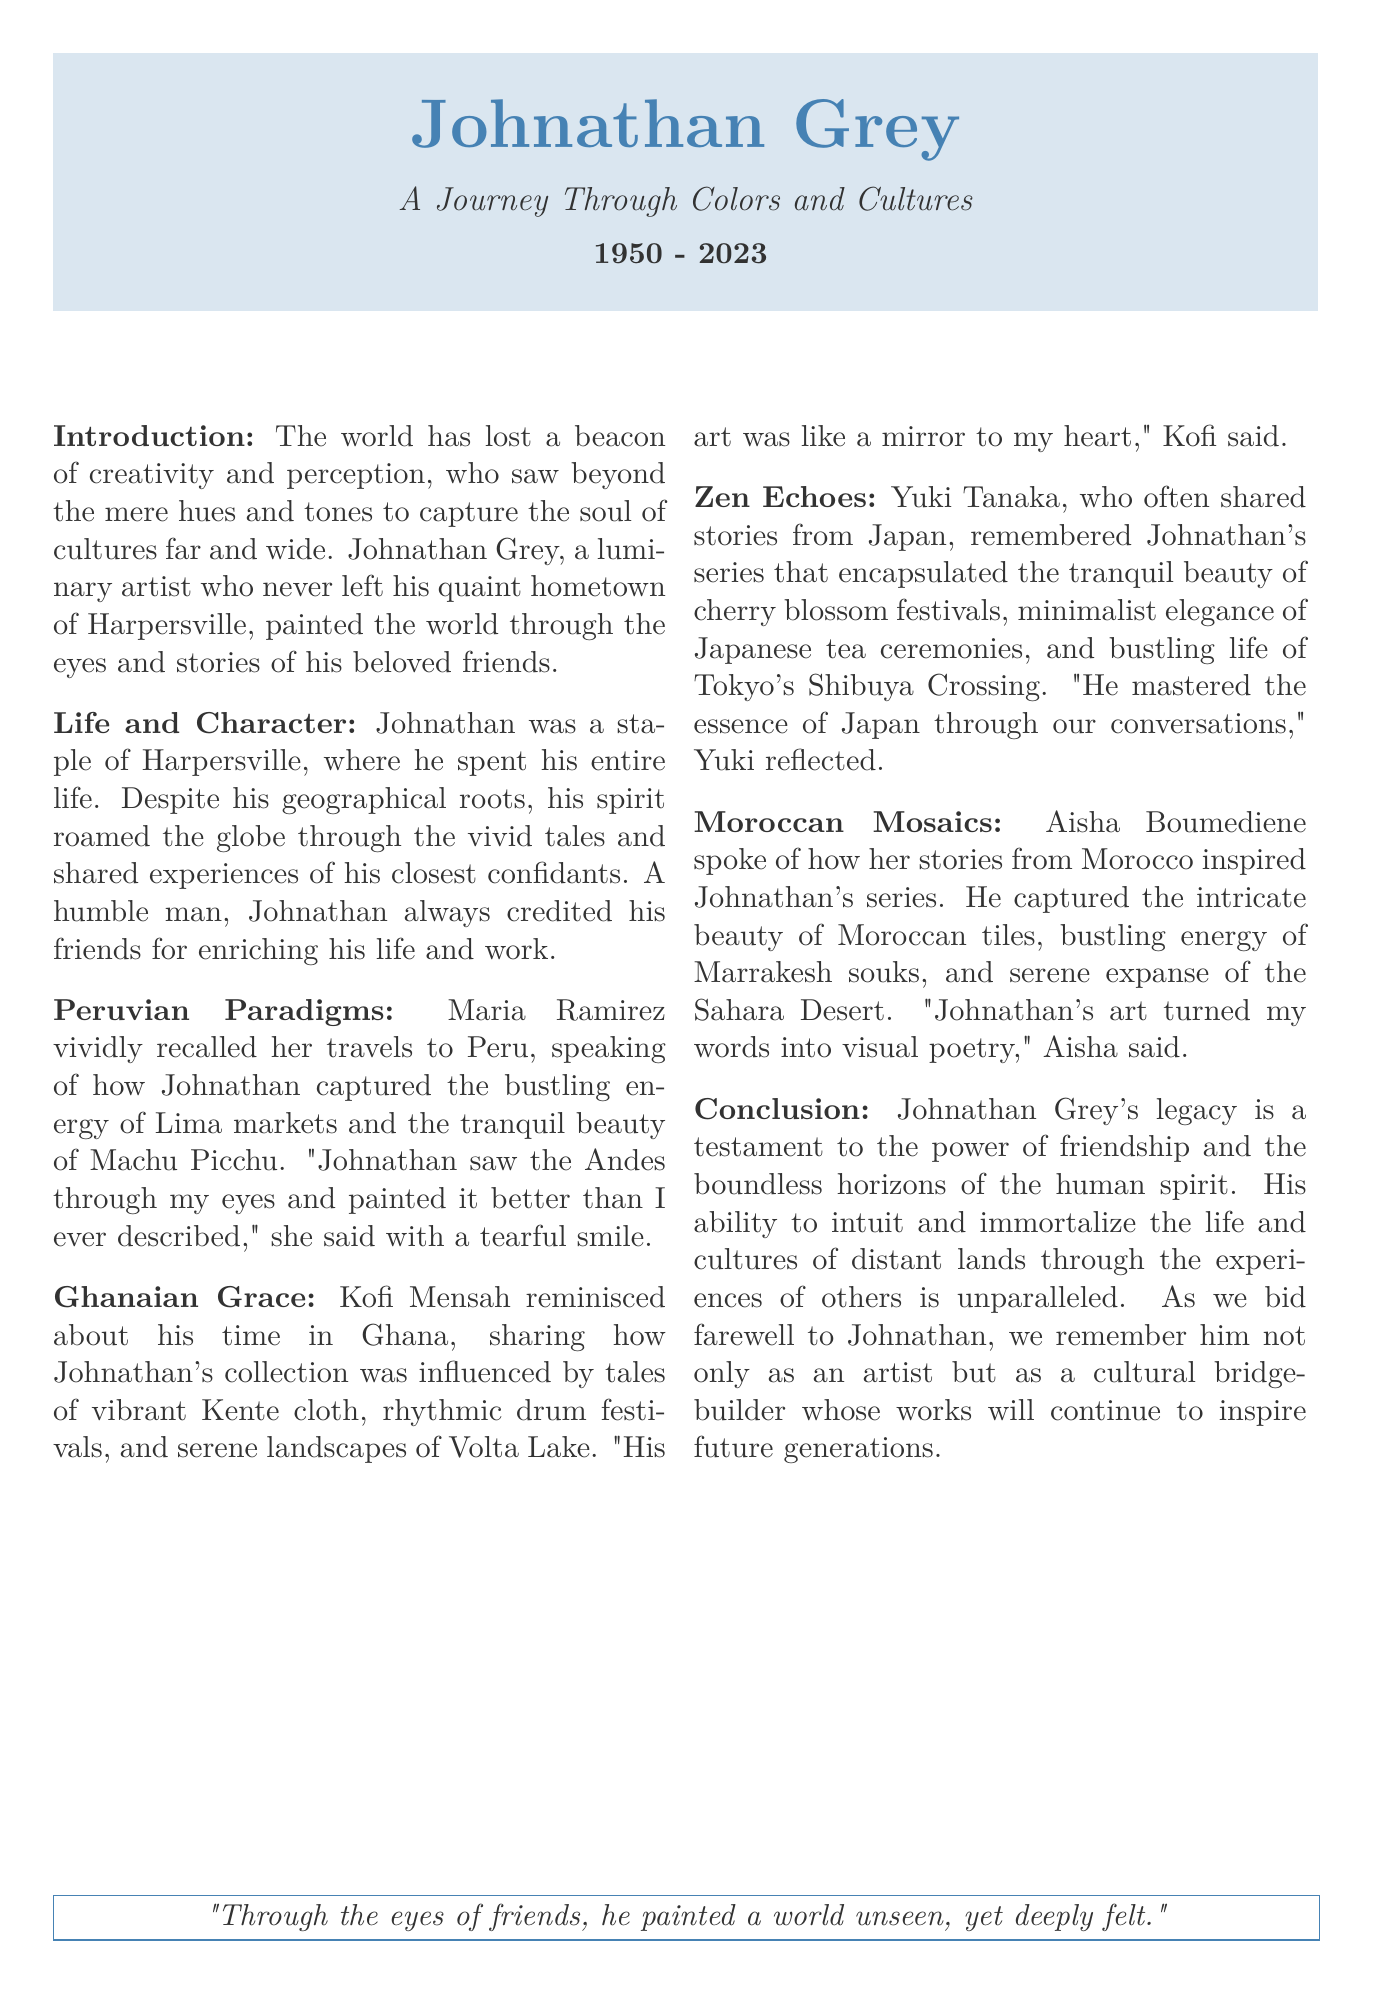What is the full name of the artist? The artist's full name is stated at the beginning of the obituary as Johnathan Grey.
Answer: Johnathan Grey What year did Johnathan Grey pass away? The obituary notes the years of his life, showing that he passed away in 2023.
Answer: 2023 In which town did Johnathan Grey spend his entire life? The document mentions that he spent his life in Harpersville.
Answer: Harpersville Which country did Maria Ramirez share stories from? The sections of the document reference Maria Ramirez's stories about Peru.
Answer: Peru What festival did Yuki Tanaka refer to when reminiscing about Johnathan's work? Yuki Tanaka spoke of cherry blossom festivals in Japan as part of her memories with Johnathan.
Answer: cherry blossom festivals How did Kofi Mensah describe Johnathan’s art? Kofi Mensah described Johnathan's art as a mirror to his heart, reflecting on its emotional depth.
Answer: a mirror to my heart What role did Johnathan Grey play in the lives of his friends? The obituary describes Johnathan Grey as a cultural bridge-builder through his friendships and art.
Answer: cultural bridge-builder What was Aisha Boumediene's nationality? Aisha Boumediene’s stories were inspired by her experiences from Morocco, indicating her connection to that culture.
Answer: Moroccan What is the central theme of Johnathan's artistic legacy? The obituary emphasizes the importance of friendship and the cultural connections he created through his artwork.
Answer: friendship What is the closing quote in the obituary? The last quote in the document reflects on Johnathan's ability to depict unseen worlds through his friendships.
Answer: "Through the eyes of friends, he painted a world unseen, yet deeply felt." 